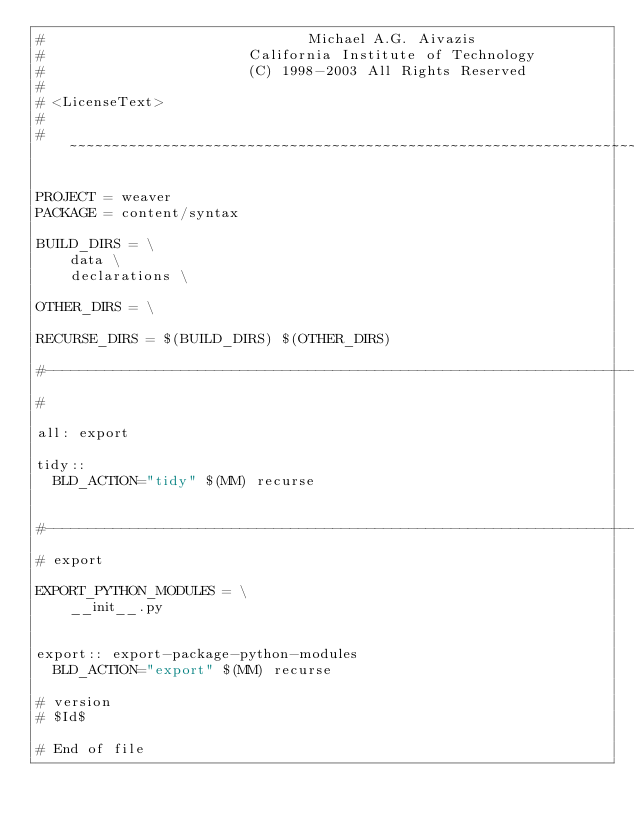<code> <loc_0><loc_0><loc_500><loc_500><_ObjectiveC_>#                               Michael A.G. Aivazis
#                        California Institute of Technology
#                        (C) 1998-2003 All Rights Reserved
#
# <LicenseText>
#
# ~~~~~~~~~~~~~~~~~~~~~~~~~~~~~~~~~~~~~~~~~~~~~~~~~~~~~~~~~~~~~~~~~~~~~~~~~~~~~~~~

PROJECT = weaver
PACKAGE = content/syntax

BUILD_DIRS = \
    data \
    declarations \

OTHER_DIRS = \

RECURSE_DIRS = $(BUILD_DIRS) $(OTHER_DIRS)

#--------------------------------------------------------------------------
#

all: export

tidy::
	BLD_ACTION="tidy" $(MM) recurse


#--------------------------------------------------------------------------
# export

EXPORT_PYTHON_MODULES = \
    __init__.py


export:: export-package-python-modules
	BLD_ACTION="export" $(MM) recurse

# version
# $Id$

# End of file
</code> 